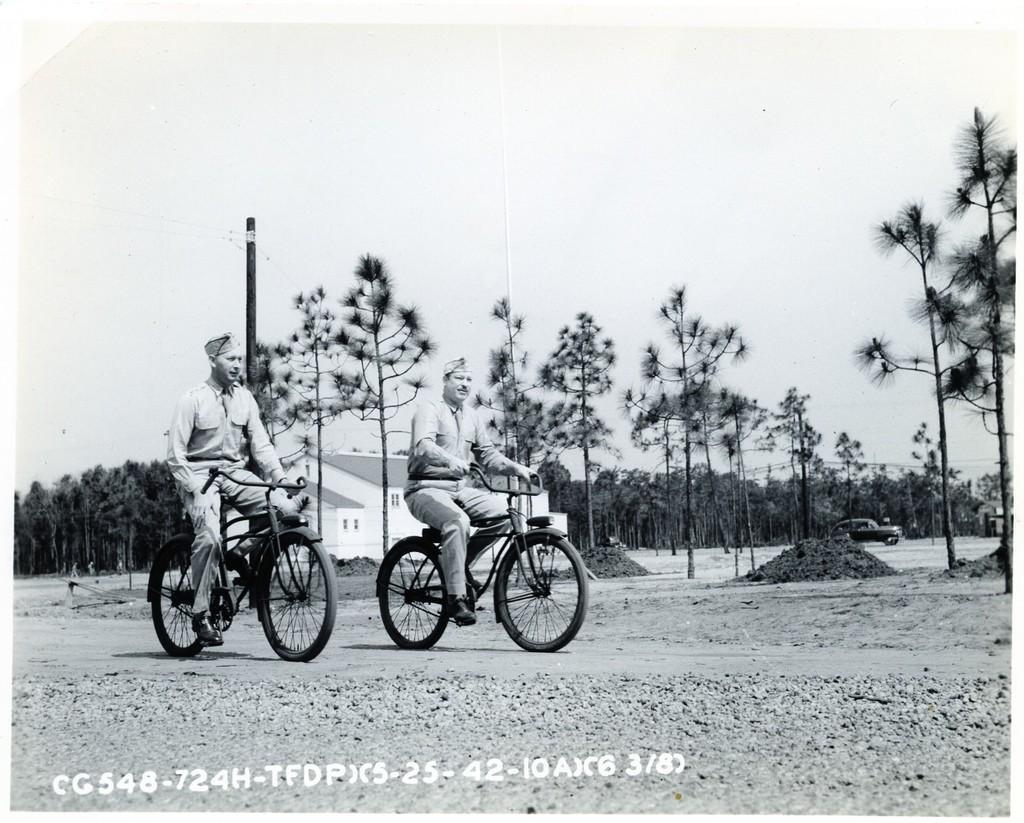In one or two sentences, can you explain what this image depicts? In this image I can see two people cycling their cycle. In the background I can see number of trees and a pole. Here I can see a building. 